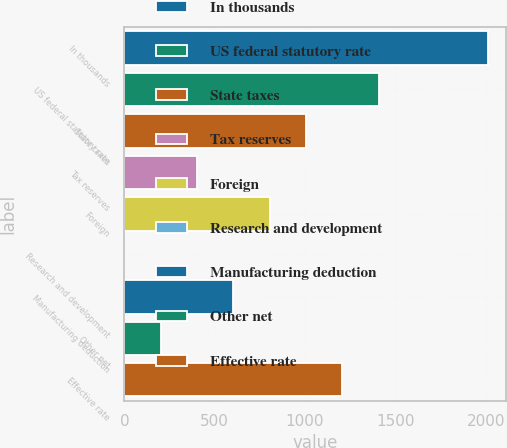Convert chart. <chart><loc_0><loc_0><loc_500><loc_500><bar_chart><fcel>In thousands<fcel>US federal statutory rate<fcel>State taxes<fcel>Tax reserves<fcel>Foreign<fcel>Research and development<fcel>Manufacturing deduction<fcel>Other net<fcel>Effective rate<nl><fcel>2012<fcel>1408.46<fcel>1006.1<fcel>402.56<fcel>804.92<fcel>0.2<fcel>603.74<fcel>201.38<fcel>1207.28<nl></chart> 